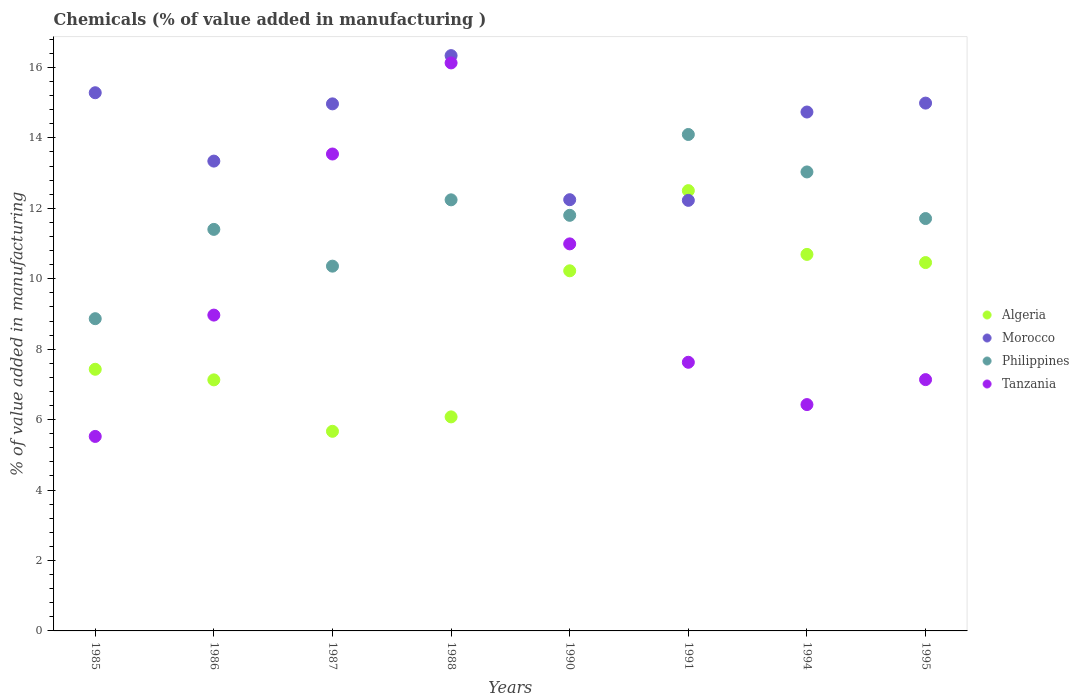How many different coloured dotlines are there?
Give a very brief answer. 4. Is the number of dotlines equal to the number of legend labels?
Keep it short and to the point. Yes. What is the value added in manufacturing chemicals in Tanzania in 1995?
Your response must be concise. 7.14. Across all years, what is the maximum value added in manufacturing chemicals in Philippines?
Your response must be concise. 14.1. Across all years, what is the minimum value added in manufacturing chemicals in Morocco?
Your response must be concise. 12.23. In which year was the value added in manufacturing chemicals in Algeria maximum?
Provide a succinct answer. 1991. What is the total value added in manufacturing chemicals in Philippines in the graph?
Give a very brief answer. 93.51. What is the difference between the value added in manufacturing chemicals in Tanzania in 1985 and that in 1994?
Give a very brief answer. -0.9. What is the difference between the value added in manufacturing chemicals in Algeria in 1988 and the value added in manufacturing chemicals in Morocco in 1995?
Offer a very short reply. -8.91. What is the average value added in manufacturing chemicals in Morocco per year?
Provide a succinct answer. 14.27. In the year 1987, what is the difference between the value added in manufacturing chemicals in Morocco and value added in manufacturing chemicals in Tanzania?
Make the answer very short. 1.42. What is the ratio of the value added in manufacturing chemicals in Tanzania in 1987 to that in 1990?
Give a very brief answer. 1.23. Is the difference between the value added in manufacturing chemicals in Morocco in 1988 and 1994 greater than the difference between the value added in manufacturing chemicals in Tanzania in 1988 and 1994?
Your response must be concise. No. What is the difference between the highest and the second highest value added in manufacturing chemicals in Philippines?
Your response must be concise. 1.06. What is the difference between the highest and the lowest value added in manufacturing chemicals in Tanzania?
Your answer should be very brief. 10.61. Is the sum of the value added in manufacturing chemicals in Tanzania in 1985 and 1987 greater than the maximum value added in manufacturing chemicals in Algeria across all years?
Offer a terse response. Yes. Is it the case that in every year, the sum of the value added in manufacturing chemicals in Morocco and value added in manufacturing chemicals in Philippines  is greater than the value added in manufacturing chemicals in Algeria?
Your answer should be very brief. Yes. Does the value added in manufacturing chemicals in Algeria monotonically increase over the years?
Keep it short and to the point. No. How many dotlines are there?
Offer a terse response. 4. How many years are there in the graph?
Offer a terse response. 8. What is the difference between two consecutive major ticks on the Y-axis?
Make the answer very short. 2. Are the values on the major ticks of Y-axis written in scientific E-notation?
Your response must be concise. No. How are the legend labels stacked?
Give a very brief answer. Vertical. What is the title of the graph?
Your response must be concise. Chemicals (% of value added in manufacturing ). Does "France" appear as one of the legend labels in the graph?
Make the answer very short. No. What is the label or title of the X-axis?
Make the answer very short. Years. What is the label or title of the Y-axis?
Keep it short and to the point. % of value added in manufacturing. What is the % of value added in manufacturing of Algeria in 1985?
Your response must be concise. 7.43. What is the % of value added in manufacturing of Morocco in 1985?
Keep it short and to the point. 15.28. What is the % of value added in manufacturing in Philippines in 1985?
Give a very brief answer. 8.87. What is the % of value added in manufacturing in Tanzania in 1985?
Offer a terse response. 5.52. What is the % of value added in manufacturing in Algeria in 1986?
Your answer should be very brief. 7.13. What is the % of value added in manufacturing in Morocco in 1986?
Offer a very short reply. 13.34. What is the % of value added in manufacturing of Philippines in 1986?
Provide a succinct answer. 11.4. What is the % of value added in manufacturing in Tanzania in 1986?
Provide a succinct answer. 8.97. What is the % of value added in manufacturing of Algeria in 1987?
Offer a very short reply. 5.67. What is the % of value added in manufacturing of Morocco in 1987?
Keep it short and to the point. 14.97. What is the % of value added in manufacturing in Philippines in 1987?
Ensure brevity in your answer.  10.36. What is the % of value added in manufacturing of Tanzania in 1987?
Your response must be concise. 13.54. What is the % of value added in manufacturing in Algeria in 1988?
Offer a terse response. 6.08. What is the % of value added in manufacturing of Morocco in 1988?
Ensure brevity in your answer.  16.34. What is the % of value added in manufacturing of Philippines in 1988?
Provide a succinct answer. 12.24. What is the % of value added in manufacturing in Tanzania in 1988?
Your answer should be very brief. 16.13. What is the % of value added in manufacturing in Algeria in 1990?
Offer a terse response. 10.23. What is the % of value added in manufacturing in Morocco in 1990?
Make the answer very short. 12.25. What is the % of value added in manufacturing in Philippines in 1990?
Make the answer very short. 11.8. What is the % of value added in manufacturing in Tanzania in 1990?
Keep it short and to the point. 10.99. What is the % of value added in manufacturing in Algeria in 1991?
Give a very brief answer. 12.5. What is the % of value added in manufacturing in Morocco in 1991?
Keep it short and to the point. 12.23. What is the % of value added in manufacturing in Philippines in 1991?
Ensure brevity in your answer.  14.1. What is the % of value added in manufacturing in Tanzania in 1991?
Offer a terse response. 7.63. What is the % of value added in manufacturing in Algeria in 1994?
Offer a very short reply. 10.69. What is the % of value added in manufacturing of Morocco in 1994?
Provide a short and direct response. 14.74. What is the % of value added in manufacturing in Philippines in 1994?
Provide a short and direct response. 13.03. What is the % of value added in manufacturing in Tanzania in 1994?
Give a very brief answer. 6.43. What is the % of value added in manufacturing of Algeria in 1995?
Provide a succinct answer. 10.46. What is the % of value added in manufacturing of Morocco in 1995?
Your answer should be compact. 14.99. What is the % of value added in manufacturing in Philippines in 1995?
Give a very brief answer. 11.71. What is the % of value added in manufacturing of Tanzania in 1995?
Give a very brief answer. 7.14. Across all years, what is the maximum % of value added in manufacturing in Algeria?
Ensure brevity in your answer.  12.5. Across all years, what is the maximum % of value added in manufacturing of Morocco?
Ensure brevity in your answer.  16.34. Across all years, what is the maximum % of value added in manufacturing of Philippines?
Ensure brevity in your answer.  14.1. Across all years, what is the maximum % of value added in manufacturing in Tanzania?
Make the answer very short. 16.13. Across all years, what is the minimum % of value added in manufacturing in Algeria?
Your response must be concise. 5.67. Across all years, what is the minimum % of value added in manufacturing of Morocco?
Offer a very short reply. 12.23. Across all years, what is the minimum % of value added in manufacturing in Philippines?
Offer a terse response. 8.87. Across all years, what is the minimum % of value added in manufacturing of Tanzania?
Provide a succinct answer. 5.52. What is the total % of value added in manufacturing in Algeria in the graph?
Provide a succinct answer. 70.19. What is the total % of value added in manufacturing in Morocco in the graph?
Offer a terse response. 114.12. What is the total % of value added in manufacturing in Philippines in the graph?
Your answer should be very brief. 93.51. What is the total % of value added in manufacturing in Tanzania in the graph?
Provide a succinct answer. 76.35. What is the difference between the % of value added in manufacturing of Algeria in 1985 and that in 1986?
Provide a short and direct response. 0.3. What is the difference between the % of value added in manufacturing in Morocco in 1985 and that in 1986?
Ensure brevity in your answer.  1.94. What is the difference between the % of value added in manufacturing in Philippines in 1985 and that in 1986?
Offer a terse response. -2.54. What is the difference between the % of value added in manufacturing in Tanzania in 1985 and that in 1986?
Keep it short and to the point. -3.45. What is the difference between the % of value added in manufacturing of Algeria in 1985 and that in 1987?
Give a very brief answer. 1.76. What is the difference between the % of value added in manufacturing of Morocco in 1985 and that in 1987?
Your answer should be very brief. 0.32. What is the difference between the % of value added in manufacturing in Philippines in 1985 and that in 1987?
Your response must be concise. -1.49. What is the difference between the % of value added in manufacturing of Tanzania in 1985 and that in 1987?
Your answer should be compact. -8.02. What is the difference between the % of value added in manufacturing of Algeria in 1985 and that in 1988?
Offer a very short reply. 1.35. What is the difference between the % of value added in manufacturing of Morocco in 1985 and that in 1988?
Offer a terse response. -1.05. What is the difference between the % of value added in manufacturing in Philippines in 1985 and that in 1988?
Offer a very short reply. -3.38. What is the difference between the % of value added in manufacturing of Tanzania in 1985 and that in 1988?
Your answer should be compact. -10.61. What is the difference between the % of value added in manufacturing in Algeria in 1985 and that in 1990?
Keep it short and to the point. -2.8. What is the difference between the % of value added in manufacturing of Morocco in 1985 and that in 1990?
Provide a succinct answer. 3.04. What is the difference between the % of value added in manufacturing of Philippines in 1985 and that in 1990?
Provide a short and direct response. -2.94. What is the difference between the % of value added in manufacturing of Tanzania in 1985 and that in 1990?
Give a very brief answer. -5.47. What is the difference between the % of value added in manufacturing of Algeria in 1985 and that in 1991?
Offer a terse response. -5.07. What is the difference between the % of value added in manufacturing of Morocco in 1985 and that in 1991?
Offer a terse response. 3.06. What is the difference between the % of value added in manufacturing of Philippines in 1985 and that in 1991?
Your answer should be compact. -5.23. What is the difference between the % of value added in manufacturing in Tanzania in 1985 and that in 1991?
Provide a short and direct response. -2.11. What is the difference between the % of value added in manufacturing of Algeria in 1985 and that in 1994?
Make the answer very short. -3.26. What is the difference between the % of value added in manufacturing in Morocco in 1985 and that in 1994?
Offer a terse response. 0.55. What is the difference between the % of value added in manufacturing of Philippines in 1985 and that in 1994?
Make the answer very short. -4.17. What is the difference between the % of value added in manufacturing in Tanzania in 1985 and that in 1994?
Your response must be concise. -0.9. What is the difference between the % of value added in manufacturing in Algeria in 1985 and that in 1995?
Provide a short and direct response. -3.03. What is the difference between the % of value added in manufacturing in Morocco in 1985 and that in 1995?
Give a very brief answer. 0.29. What is the difference between the % of value added in manufacturing of Philippines in 1985 and that in 1995?
Give a very brief answer. -2.84. What is the difference between the % of value added in manufacturing of Tanzania in 1985 and that in 1995?
Offer a very short reply. -1.61. What is the difference between the % of value added in manufacturing of Algeria in 1986 and that in 1987?
Provide a short and direct response. 1.46. What is the difference between the % of value added in manufacturing in Morocco in 1986 and that in 1987?
Give a very brief answer. -1.63. What is the difference between the % of value added in manufacturing of Philippines in 1986 and that in 1987?
Provide a short and direct response. 1.04. What is the difference between the % of value added in manufacturing of Tanzania in 1986 and that in 1987?
Provide a short and direct response. -4.57. What is the difference between the % of value added in manufacturing of Algeria in 1986 and that in 1988?
Offer a very short reply. 1.05. What is the difference between the % of value added in manufacturing in Morocco in 1986 and that in 1988?
Your answer should be compact. -3. What is the difference between the % of value added in manufacturing in Philippines in 1986 and that in 1988?
Provide a short and direct response. -0.84. What is the difference between the % of value added in manufacturing in Tanzania in 1986 and that in 1988?
Provide a short and direct response. -7.16. What is the difference between the % of value added in manufacturing of Algeria in 1986 and that in 1990?
Ensure brevity in your answer.  -3.1. What is the difference between the % of value added in manufacturing in Morocco in 1986 and that in 1990?
Make the answer very short. 1.1. What is the difference between the % of value added in manufacturing of Philippines in 1986 and that in 1990?
Your answer should be compact. -0.4. What is the difference between the % of value added in manufacturing in Tanzania in 1986 and that in 1990?
Offer a very short reply. -2.02. What is the difference between the % of value added in manufacturing of Algeria in 1986 and that in 1991?
Provide a short and direct response. -5.37. What is the difference between the % of value added in manufacturing in Morocco in 1986 and that in 1991?
Your response must be concise. 1.11. What is the difference between the % of value added in manufacturing of Philippines in 1986 and that in 1991?
Ensure brevity in your answer.  -2.7. What is the difference between the % of value added in manufacturing of Tanzania in 1986 and that in 1991?
Provide a short and direct response. 1.34. What is the difference between the % of value added in manufacturing of Algeria in 1986 and that in 1994?
Your answer should be compact. -3.56. What is the difference between the % of value added in manufacturing of Morocco in 1986 and that in 1994?
Your answer should be very brief. -1.39. What is the difference between the % of value added in manufacturing of Philippines in 1986 and that in 1994?
Offer a terse response. -1.63. What is the difference between the % of value added in manufacturing of Tanzania in 1986 and that in 1994?
Provide a short and direct response. 2.54. What is the difference between the % of value added in manufacturing in Algeria in 1986 and that in 1995?
Make the answer very short. -3.33. What is the difference between the % of value added in manufacturing in Morocco in 1986 and that in 1995?
Your response must be concise. -1.65. What is the difference between the % of value added in manufacturing in Philippines in 1986 and that in 1995?
Ensure brevity in your answer.  -0.31. What is the difference between the % of value added in manufacturing in Tanzania in 1986 and that in 1995?
Offer a very short reply. 1.83. What is the difference between the % of value added in manufacturing in Algeria in 1987 and that in 1988?
Your answer should be compact. -0.41. What is the difference between the % of value added in manufacturing in Morocco in 1987 and that in 1988?
Your response must be concise. -1.37. What is the difference between the % of value added in manufacturing of Philippines in 1987 and that in 1988?
Offer a terse response. -1.88. What is the difference between the % of value added in manufacturing in Tanzania in 1987 and that in 1988?
Your answer should be very brief. -2.59. What is the difference between the % of value added in manufacturing of Algeria in 1987 and that in 1990?
Keep it short and to the point. -4.56. What is the difference between the % of value added in manufacturing of Morocco in 1987 and that in 1990?
Give a very brief answer. 2.72. What is the difference between the % of value added in manufacturing in Philippines in 1987 and that in 1990?
Your answer should be very brief. -1.44. What is the difference between the % of value added in manufacturing of Tanzania in 1987 and that in 1990?
Give a very brief answer. 2.55. What is the difference between the % of value added in manufacturing in Algeria in 1987 and that in 1991?
Your response must be concise. -6.83. What is the difference between the % of value added in manufacturing of Morocco in 1987 and that in 1991?
Offer a very short reply. 2.74. What is the difference between the % of value added in manufacturing of Philippines in 1987 and that in 1991?
Keep it short and to the point. -3.74. What is the difference between the % of value added in manufacturing of Tanzania in 1987 and that in 1991?
Your answer should be compact. 5.91. What is the difference between the % of value added in manufacturing of Algeria in 1987 and that in 1994?
Your answer should be very brief. -5.02. What is the difference between the % of value added in manufacturing of Morocco in 1987 and that in 1994?
Ensure brevity in your answer.  0.23. What is the difference between the % of value added in manufacturing of Philippines in 1987 and that in 1994?
Make the answer very short. -2.68. What is the difference between the % of value added in manufacturing of Tanzania in 1987 and that in 1994?
Offer a very short reply. 7.12. What is the difference between the % of value added in manufacturing of Algeria in 1987 and that in 1995?
Provide a short and direct response. -4.79. What is the difference between the % of value added in manufacturing in Morocco in 1987 and that in 1995?
Ensure brevity in your answer.  -0.02. What is the difference between the % of value added in manufacturing in Philippines in 1987 and that in 1995?
Offer a terse response. -1.35. What is the difference between the % of value added in manufacturing of Tanzania in 1987 and that in 1995?
Ensure brevity in your answer.  6.41. What is the difference between the % of value added in manufacturing of Algeria in 1988 and that in 1990?
Offer a very short reply. -4.15. What is the difference between the % of value added in manufacturing in Morocco in 1988 and that in 1990?
Your answer should be compact. 4.09. What is the difference between the % of value added in manufacturing of Philippines in 1988 and that in 1990?
Your response must be concise. 0.44. What is the difference between the % of value added in manufacturing of Tanzania in 1988 and that in 1990?
Ensure brevity in your answer.  5.14. What is the difference between the % of value added in manufacturing of Algeria in 1988 and that in 1991?
Your answer should be compact. -6.42. What is the difference between the % of value added in manufacturing in Morocco in 1988 and that in 1991?
Your answer should be compact. 4.11. What is the difference between the % of value added in manufacturing of Philippines in 1988 and that in 1991?
Give a very brief answer. -1.86. What is the difference between the % of value added in manufacturing of Tanzania in 1988 and that in 1991?
Your answer should be very brief. 8.5. What is the difference between the % of value added in manufacturing of Algeria in 1988 and that in 1994?
Keep it short and to the point. -4.61. What is the difference between the % of value added in manufacturing in Morocco in 1988 and that in 1994?
Give a very brief answer. 1.6. What is the difference between the % of value added in manufacturing in Philippines in 1988 and that in 1994?
Offer a very short reply. -0.79. What is the difference between the % of value added in manufacturing of Tanzania in 1988 and that in 1994?
Provide a succinct answer. 9.7. What is the difference between the % of value added in manufacturing of Algeria in 1988 and that in 1995?
Keep it short and to the point. -4.38. What is the difference between the % of value added in manufacturing of Morocco in 1988 and that in 1995?
Ensure brevity in your answer.  1.35. What is the difference between the % of value added in manufacturing of Philippines in 1988 and that in 1995?
Keep it short and to the point. 0.53. What is the difference between the % of value added in manufacturing of Tanzania in 1988 and that in 1995?
Ensure brevity in your answer.  8.99. What is the difference between the % of value added in manufacturing in Algeria in 1990 and that in 1991?
Your response must be concise. -2.28. What is the difference between the % of value added in manufacturing of Morocco in 1990 and that in 1991?
Offer a terse response. 0.02. What is the difference between the % of value added in manufacturing in Philippines in 1990 and that in 1991?
Your answer should be very brief. -2.3. What is the difference between the % of value added in manufacturing of Tanzania in 1990 and that in 1991?
Your answer should be compact. 3.36. What is the difference between the % of value added in manufacturing in Algeria in 1990 and that in 1994?
Make the answer very short. -0.47. What is the difference between the % of value added in manufacturing in Morocco in 1990 and that in 1994?
Keep it short and to the point. -2.49. What is the difference between the % of value added in manufacturing in Philippines in 1990 and that in 1994?
Ensure brevity in your answer.  -1.23. What is the difference between the % of value added in manufacturing in Tanzania in 1990 and that in 1994?
Your response must be concise. 4.56. What is the difference between the % of value added in manufacturing of Algeria in 1990 and that in 1995?
Offer a very short reply. -0.23. What is the difference between the % of value added in manufacturing of Morocco in 1990 and that in 1995?
Offer a very short reply. -2.74. What is the difference between the % of value added in manufacturing of Philippines in 1990 and that in 1995?
Provide a short and direct response. 0.09. What is the difference between the % of value added in manufacturing in Tanzania in 1990 and that in 1995?
Provide a succinct answer. 3.85. What is the difference between the % of value added in manufacturing in Algeria in 1991 and that in 1994?
Make the answer very short. 1.81. What is the difference between the % of value added in manufacturing in Morocco in 1991 and that in 1994?
Make the answer very short. -2.51. What is the difference between the % of value added in manufacturing of Philippines in 1991 and that in 1994?
Provide a succinct answer. 1.06. What is the difference between the % of value added in manufacturing in Tanzania in 1991 and that in 1994?
Keep it short and to the point. 1.2. What is the difference between the % of value added in manufacturing of Algeria in 1991 and that in 1995?
Give a very brief answer. 2.04. What is the difference between the % of value added in manufacturing in Morocco in 1991 and that in 1995?
Keep it short and to the point. -2.76. What is the difference between the % of value added in manufacturing in Philippines in 1991 and that in 1995?
Your response must be concise. 2.39. What is the difference between the % of value added in manufacturing in Tanzania in 1991 and that in 1995?
Ensure brevity in your answer.  0.49. What is the difference between the % of value added in manufacturing in Algeria in 1994 and that in 1995?
Your answer should be compact. 0.23. What is the difference between the % of value added in manufacturing of Morocco in 1994 and that in 1995?
Offer a very short reply. -0.25. What is the difference between the % of value added in manufacturing of Philippines in 1994 and that in 1995?
Ensure brevity in your answer.  1.32. What is the difference between the % of value added in manufacturing of Tanzania in 1994 and that in 1995?
Give a very brief answer. -0.71. What is the difference between the % of value added in manufacturing of Algeria in 1985 and the % of value added in manufacturing of Morocco in 1986?
Your answer should be very brief. -5.91. What is the difference between the % of value added in manufacturing in Algeria in 1985 and the % of value added in manufacturing in Philippines in 1986?
Offer a terse response. -3.97. What is the difference between the % of value added in manufacturing in Algeria in 1985 and the % of value added in manufacturing in Tanzania in 1986?
Offer a very short reply. -1.54. What is the difference between the % of value added in manufacturing in Morocco in 1985 and the % of value added in manufacturing in Philippines in 1986?
Offer a very short reply. 3.88. What is the difference between the % of value added in manufacturing in Morocco in 1985 and the % of value added in manufacturing in Tanzania in 1986?
Offer a very short reply. 6.31. What is the difference between the % of value added in manufacturing of Philippines in 1985 and the % of value added in manufacturing of Tanzania in 1986?
Provide a short and direct response. -0.1. What is the difference between the % of value added in manufacturing of Algeria in 1985 and the % of value added in manufacturing of Morocco in 1987?
Offer a terse response. -7.54. What is the difference between the % of value added in manufacturing of Algeria in 1985 and the % of value added in manufacturing of Philippines in 1987?
Offer a terse response. -2.93. What is the difference between the % of value added in manufacturing in Algeria in 1985 and the % of value added in manufacturing in Tanzania in 1987?
Your response must be concise. -6.11. What is the difference between the % of value added in manufacturing in Morocco in 1985 and the % of value added in manufacturing in Philippines in 1987?
Offer a very short reply. 4.92. What is the difference between the % of value added in manufacturing of Morocco in 1985 and the % of value added in manufacturing of Tanzania in 1987?
Keep it short and to the point. 1.74. What is the difference between the % of value added in manufacturing in Philippines in 1985 and the % of value added in manufacturing in Tanzania in 1987?
Your answer should be compact. -4.68. What is the difference between the % of value added in manufacturing in Algeria in 1985 and the % of value added in manufacturing in Morocco in 1988?
Your response must be concise. -8.91. What is the difference between the % of value added in manufacturing in Algeria in 1985 and the % of value added in manufacturing in Philippines in 1988?
Your response must be concise. -4.81. What is the difference between the % of value added in manufacturing in Algeria in 1985 and the % of value added in manufacturing in Tanzania in 1988?
Offer a terse response. -8.7. What is the difference between the % of value added in manufacturing of Morocco in 1985 and the % of value added in manufacturing of Philippines in 1988?
Provide a short and direct response. 3.04. What is the difference between the % of value added in manufacturing in Morocco in 1985 and the % of value added in manufacturing in Tanzania in 1988?
Your answer should be very brief. -0.85. What is the difference between the % of value added in manufacturing of Philippines in 1985 and the % of value added in manufacturing of Tanzania in 1988?
Make the answer very short. -7.26. What is the difference between the % of value added in manufacturing of Algeria in 1985 and the % of value added in manufacturing of Morocco in 1990?
Give a very brief answer. -4.82. What is the difference between the % of value added in manufacturing of Algeria in 1985 and the % of value added in manufacturing of Philippines in 1990?
Ensure brevity in your answer.  -4.37. What is the difference between the % of value added in manufacturing of Algeria in 1985 and the % of value added in manufacturing of Tanzania in 1990?
Keep it short and to the point. -3.56. What is the difference between the % of value added in manufacturing in Morocco in 1985 and the % of value added in manufacturing in Philippines in 1990?
Provide a succinct answer. 3.48. What is the difference between the % of value added in manufacturing of Morocco in 1985 and the % of value added in manufacturing of Tanzania in 1990?
Your response must be concise. 4.29. What is the difference between the % of value added in manufacturing of Philippines in 1985 and the % of value added in manufacturing of Tanzania in 1990?
Offer a terse response. -2.12. What is the difference between the % of value added in manufacturing in Algeria in 1985 and the % of value added in manufacturing in Morocco in 1991?
Offer a very short reply. -4.8. What is the difference between the % of value added in manufacturing of Algeria in 1985 and the % of value added in manufacturing of Philippines in 1991?
Offer a very short reply. -6.67. What is the difference between the % of value added in manufacturing in Algeria in 1985 and the % of value added in manufacturing in Tanzania in 1991?
Your answer should be very brief. -0.2. What is the difference between the % of value added in manufacturing in Morocco in 1985 and the % of value added in manufacturing in Philippines in 1991?
Offer a very short reply. 1.19. What is the difference between the % of value added in manufacturing in Morocco in 1985 and the % of value added in manufacturing in Tanzania in 1991?
Make the answer very short. 7.65. What is the difference between the % of value added in manufacturing in Philippines in 1985 and the % of value added in manufacturing in Tanzania in 1991?
Offer a very short reply. 1.24. What is the difference between the % of value added in manufacturing in Algeria in 1985 and the % of value added in manufacturing in Morocco in 1994?
Provide a succinct answer. -7.31. What is the difference between the % of value added in manufacturing of Algeria in 1985 and the % of value added in manufacturing of Philippines in 1994?
Ensure brevity in your answer.  -5.6. What is the difference between the % of value added in manufacturing of Algeria in 1985 and the % of value added in manufacturing of Tanzania in 1994?
Offer a terse response. 1. What is the difference between the % of value added in manufacturing in Morocco in 1985 and the % of value added in manufacturing in Philippines in 1994?
Keep it short and to the point. 2.25. What is the difference between the % of value added in manufacturing of Morocco in 1985 and the % of value added in manufacturing of Tanzania in 1994?
Your response must be concise. 8.86. What is the difference between the % of value added in manufacturing of Philippines in 1985 and the % of value added in manufacturing of Tanzania in 1994?
Keep it short and to the point. 2.44. What is the difference between the % of value added in manufacturing of Algeria in 1985 and the % of value added in manufacturing of Morocco in 1995?
Ensure brevity in your answer.  -7.56. What is the difference between the % of value added in manufacturing of Algeria in 1985 and the % of value added in manufacturing of Philippines in 1995?
Keep it short and to the point. -4.28. What is the difference between the % of value added in manufacturing of Algeria in 1985 and the % of value added in manufacturing of Tanzania in 1995?
Ensure brevity in your answer.  0.29. What is the difference between the % of value added in manufacturing of Morocco in 1985 and the % of value added in manufacturing of Philippines in 1995?
Ensure brevity in your answer.  3.57. What is the difference between the % of value added in manufacturing in Morocco in 1985 and the % of value added in manufacturing in Tanzania in 1995?
Ensure brevity in your answer.  8.15. What is the difference between the % of value added in manufacturing of Philippines in 1985 and the % of value added in manufacturing of Tanzania in 1995?
Provide a succinct answer. 1.73. What is the difference between the % of value added in manufacturing of Algeria in 1986 and the % of value added in manufacturing of Morocco in 1987?
Provide a succinct answer. -7.84. What is the difference between the % of value added in manufacturing of Algeria in 1986 and the % of value added in manufacturing of Philippines in 1987?
Ensure brevity in your answer.  -3.23. What is the difference between the % of value added in manufacturing in Algeria in 1986 and the % of value added in manufacturing in Tanzania in 1987?
Your answer should be compact. -6.41. What is the difference between the % of value added in manufacturing of Morocco in 1986 and the % of value added in manufacturing of Philippines in 1987?
Your response must be concise. 2.98. What is the difference between the % of value added in manufacturing in Morocco in 1986 and the % of value added in manufacturing in Tanzania in 1987?
Give a very brief answer. -0.2. What is the difference between the % of value added in manufacturing in Philippines in 1986 and the % of value added in manufacturing in Tanzania in 1987?
Provide a succinct answer. -2.14. What is the difference between the % of value added in manufacturing in Algeria in 1986 and the % of value added in manufacturing in Morocco in 1988?
Keep it short and to the point. -9.21. What is the difference between the % of value added in manufacturing of Algeria in 1986 and the % of value added in manufacturing of Philippines in 1988?
Keep it short and to the point. -5.11. What is the difference between the % of value added in manufacturing in Algeria in 1986 and the % of value added in manufacturing in Tanzania in 1988?
Offer a very short reply. -9. What is the difference between the % of value added in manufacturing of Morocco in 1986 and the % of value added in manufacturing of Philippines in 1988?
Provide a short and direct response. 1.1. What is the difference between the % of value added in manufacturing in Morocco in 1986 and the % of value added in manufacturing in Tanzania in 1988?
Your answer should be very brief. -2.79. What is the difference between the % of value added in manufacturing in Philippines in 1986 and the % of value added in manufacturing in Tanzania in 1988?
Provide a succinct answer. -4.73. What is the difference between the % of value added in manufacturing of Algeria in 1986 and the % of value added in manufacturing of Morocco in 1990?
Offer a very short reply. -5.12. What is the difference between the % of value added in manufacturing in Algeria in 1986 and the % of value added in manufacturing in Philippines in 1990?
Provide a succinct answer. -4.67. What is the difference between the % of value added in manufacturing in Algeria in 1986 and the % of value added in manufacturing in Tanzania in 1990?
Offer a very short reply. -3.86. What is the difference between the % of value added in manufacturing in Morocco in 1986 and the % of value added in manufacturing in Philippines in 1990?
Keep it short and to the point. 1.54. What is the difference between the % of value added in manufacturing of Morocco in 1986 and the % of value added in manufacturing of Tanzania in 1990?
Offer a terse response. 2.35. What is the difference between the % of value added in manufacturing in Philippines in 1986 and the % of value added in manufacturing in Tanzania in 1990?
Ensure brevity in your answer.  0.41. What is the difference between the % of value added in manufacturing in Algeria in 1986 and the % of value added in manufacturing in Morocco in 1991?
Offer a terse response. -5.1. What is the difference between the % of value added in manufacturing in Algeria in 1986 and the % of value added in manufacturing in Philippines in 1991?
Offer a very short reply. -6.97. What is the difference between the % of value added in manufacturing in Algeria in 1986 and the % of value added in manufacturing in Tanzania in 1991?
Offer a terse response. -0.5. What is the difference between the % of value added in manufacturing of Morocco in 1986 and the % of value added in manufacturing of Philippines in 1991?
Your response must be concise. -0.76. What is the difference between the % of value added in manufacturing of Morocco in 1986 and the % of value added in manufacturing of Tanzania in 1991?
Offer a terse response. 5.71. What is the difference between the % of value added in manufacturing in Philippines in 1986 and the % of value added in manufacturing in Tanzania in 1991?
Provide a succinct answer. 3.77. What is the difference between the % of value added in manufacturing in Algeria in 1986 and the % of value added in manufacturing in Morocco in 1994?
Provide a short and direct response. -7.61. What is the difference between the % of value added in manufacturing in Algeria in 1986 and the % of value added in manufacturing in Philippines in 1994?
Your response must be concise. -5.9. What is the difference between the % of value added in manufacturing of Algeria in 1986 and the % of value added in manufacturing of Tanzania in 1994?
Provide a short and direct response. 0.7. What is the difference between the % of value added in manufacturing of Morocco in 1986 and the % of value added in manufacturing of Philippines in 1994?
Your answer should be compact. 0.31. What is the difference between the % of value added in manufacturing of Morocco in 1986 and the % of value added in manufacturing of Tanzania in 1994?
Keep it short and to the point. 6.91. What is the difference between the % of value added in manufacturing in Philippines in 1986 and the % of value added in manufacturing in Tanzania in 1994?
Your response must be concise. 4.97. What is the difference between the % of value added in manufacturing in Algeria in 1986 and the % of value added in manufacturing in Morocco in 1995?
Provide a succinct answer. -7.86. What is the difference between the % of value added in manufacturing in Algeria in 1986 and the % of value added in manufacturing in Philippines in 1995?
Offer a terse response. -4.58. What is the difference between the % of value added in manufacturing in Algeria in 1986 and the % of value added in manufacturing in Tanzania in 1995?
Ensure brevity in your answer.  -0.01. What is the difference between the % of value added in manufacturing in Morocco in 1986 and the % of value added in manufacturing in Philippines in 1995?
Provide a succinct answer. 1.63. What is the difference between the % of value added in manufacturing of Morocco in 1986 and the % of value added in manufacturing of Tanzania in 1995?
Your response must be concise. 6.21. What is the difference between the % of value added in manufacturing in Philippines in 1986 and the % of value added in manufacturing in Tanzania in 1995?
Provide a short and direct response. 4.27. What is the difference between the % of value added in manufacturing of Algeria in 1987 and the % of value added in manufacturing of Morocco in 1988?
Your response must be concise. -10.67. What is the difference between the % of value added in manufacturing of Algeria in 1987 and the % of value added in manufacturing of Philippines in 1988?
Your response must be concise. -6.57. What is the difference between the % of value added in manufacturing of Algeria in 1987 and the % of value added in manufacturing of Tanzania in 1988?
Your answer should be very brief. -10.46. What is the difference between the % of value added in manufacturing in Morocco in 1987 and the % of value added in manufacturing in Philippines in 1988?
Your answer should be compact. 2.73. What is the difference between the % of value added in manufacturing in Morocco in 1987 and the % of value added in manufacturing in Tanzania in 1988?
Give a very brief answer. -1.16. What is the difference between the % of value added in manufacturing in Philippines in 1987 and the % of value added in manufacturing in Tanzania in 1988?
Your answer should be very brief. -5.77. What is the difference between the % of value added in manufacturing in Algeria in 1987 and the % of value added in manufacturing in Morocco in 1990?
Your answer should be very brief. -6.58. What is the difference between the % of value added in manufacturing in Algeria in 1987 and the % of value added in manufacturing in Philippines in 1990?
Provide a succinct answer. -6.13. What is the difference between the % of value added in manufacturing in Algeria in 1987 and the % of value added in manufacturing in Tanzania in 1990?
Provide a short and direct response. -5.32. What is the difference between the % of value added in manufacturing in Morocco in 1987 and the % of value added in manufacturing in Philippines in 1990?
Make the answer very short. 3.17. What is the difference between the % of value added in manufacturing in Morocco in 1987 and the % of value added in manufacturing in Tanzania in 1990?
Your response must be concise. 3.98. What is the difference between the % of value added in manufacturing of Philippines in 1987 and the % of value added in manufacturing of Tanzania in 1990?
Provide a short and direct response. -0.63. What is the difference between the % of value added in manufacturing of Algeria in 1987 and the % of value added in manufacturing of Morocco in 1991?
Your answer should be compact. -6.56. What is the difference between the % of value added in manufacturing of Algeria in 1987 and the % of value added in manufacturing of Philippines in 1991?
Your answer should be compact. -8.43. What is the difference between the % of value added in manufacturing of Algeria in 1987 and the % of value added in manufacturing of Tanzania in 1991?
Your answer should be very brief. -1.96. What is the difference between the % of value added in manufacturing of Morocco in 1987 and the % of value added in manufacturing of Philippines in 1991?
Your answer should be very brief. 0.87. What is the difference between the % of value added in manufacturing of Morocco in 1987 and the % of value added in manufacturing of Tanzania in 1991?
Provide a succinct answer. 7.34. What is the difference between the % of value added in manufacturing of Philippines in 1987 and the % of value added in manufacturing of Tanzania in 1991?
Your response must be concise. 2.73. What is the difference between the % of value added in manufacturing in Algeria in 1987 and the % of value added in manufacturing in Morocco in 1994?
Offer a very short reply. -9.07. What is the difference between the % of value added in manufacturing in Algeria in 1987 and the % of value added in manufacturing in Philippines in 1994?
Your answer should be very brief. -7.37. What is the difference between the % of value added in manufacturing of Algeria in 1987 and the % of value added in manufacturing of Tanzania in 1994?
Make the answer very short. -0.76. What is the difference between the % of value added in manufacturing in Morocco in 1987 and the % of value added in manufacturing in Philippines in 1994?
Keep it short and to the point. 1.93. What is the difference between the % of value added in manufacturing in Morocco in 1987 and the % of value added in manufacturing in Tanzania in 1994?
Give a very brief answer. 8.54. What is the difference between the % of value added in manufacturing of Philippines in 1987 and the % of value added in manufacturing of Tanzania in 1994?
Offer a terse response. 3.93. What is the difference between the % of value added in manufacturing in Algeria in 1987 and the % of value added in manufacturing in Morocco in 1995?
Give a very brief answer. -9.32. What is the difference between the % of value added in manufacturing in Algeria in 1987 and the % of value added in manufacturing in Philippines in 1995?
Give a very brief answer. -6.04. What is the difference between the % of value added in manufacturing in Algeria in 1987 and the % of value added in manufacturing in Tanzania in 1995?
Make the answer very short. -1.47. What is the difference between the % of value added in manufacturing of Morocco in 1987 and the % of value added in manufacturing of Philippines in 1995?
Give a very brief answer. 3.26. What is the difference between the % of value added in manufacturing of Morocco in 1987 and the % of value added in manufacturing of Tanzania in 1995?
Your answer should be compact. 7.83. What is the difference between the % of value added in manufacturing of Philippines in 1987 and the % of value added in manufacturing of Tanzania in 1995?
Provide a short and direct response. 3.22. What is the difference between the % of value added in manufacturing in Algeria in 1988 and the % of value added in manufacturing in Morocco in 1990?
Provide a succinct answer. -6.17. What is the difference between the % of value added in manufacturing of Algeria in 1988 and the % of value added in manufacturing of Philippines in 1990?
Ensure brevity in your answer.  -5.72. What is the difference between the % of value added in manufacturing in Algeria in 1988 and the % of value added in manufacturing in Tanzania in 1990?
Ensure brevity in your answer.  -4.91. What is the difference between the % of value added in manufacturing in Morocco in 1988 and the % of value added in manufacturing in Philippines in 1990?
Your response must be concise. 4.54. What is the difference between the % of value added in manufacturing in Morocco in 1988 and the % of value added in manufacturing in Tanzania in 1990?
Give a very brief answer. 5.35. What is the difference between the % of value added in manufacturing of Philippines in 1988 and the % of value added in manufacturing of Tanzania in 1990?
Provide a short and direct response. 1.25. What is the difference between the % of value added in manufacturing in Algeria in 1988 and the % of value added in manufacturing in Morocco in 1991?
Ensure brevity in your answer.  -6.15. What is the difference between the % of value added in manufacturing in Algeria in 1988 and the % of value added in manufacturing in Philippines in 1991?
Ensure brevity in your answer.  -8.02. What is the difference between the % of value added in manufacturing in Algeria in 1988 and the % of value added in manufacturing in Tanzania in 1991?
Your answer should be very brief. -1.55. What is the difference between the % of value added in manufacturing in Morocco in 1988 and the % of value added in manufacturing in Philippines in 1991?
Provide a short and direct response. 2.24. What is the difference between the % of value added in manufacturing of Morocco in 1988 and the % of value added in manufacturing of Tanzania in 1991?
Provide a short and direct response. 8.71. What is the difference between the % of value added in manufacturing in Philippines in 1988 and the % of value added in manufacturing in Tanzania in 1991?
Ensure brevity in your answer.  4.61. What is the difference between the % of value added in manufacturing of Algeria in 1988 and the % of value added in manufacturing of Morocco in 1994?
Make the answer very short. -8.66. What is the difference between the % of value added in manufacturing in Algeria in 1988 and the % of value added in manufacturing in Philippines in 1994?
Your answer should be very brief. -6.96. What is the difference between the % of value added in manufacturing of Algeria in 1988 and the % of value added in manufacturing of Tanzania in 1994?
Your answer should be very brief. -0.35. What is the difference between the % of value added in manufacturing of Morocco in 1988 and the % of value added in manufacturing of Philippines in 1994?
Your answer should be very brief. 3.3. What is the difference between the % of value added in manufacturing of Morocco in 1988 and the % of value added in manufacturing of Tanzania in 1994?
Keep it short and to the point. 9.91. What is the difference between the % of value added in manufacturing in Philippines in 1988 and the % of value added in manufacturing in Tanzania in 1994?
Your response must be concise. 5.81. What is the difference between the % of value added in manufacturing in Algeria in 1988 and the % of value added in manufacturing in Morocco in 1995?
Your answer should be very brief. -8.91. What is the difference between the % of value added in manufacturing in Algeria in 1988 and the % of value added in manufacturing in Philippines in 1995?
Ensure brevity in your answer.  -5.63. What is the difference between the % of value added in manufacturing in Algeria in 1988 and the % of value added in manufacturing in Tanzania in 1995?
Give a very brief answer. -1.06. What is the difference between the % of value added in manufacturing in Morocco in 1988 and the % of value added in manufacturing in Philippines in 1995?
Your response must be concise. 4.63. What is the difference between the % of value added in manufacturing in Morocco in 1988 and the % of value added in manufacturing in Tanzania in 1995?
Make the answer very short. 9.2. What is the difference between the % of value added in manufacturing of Philippines in 1988 and the % of value added in manufacturing of Tanzania in 1995?
Offer a very short reply. 5.11. What is the difference between the % of value added in manufacturing of Algeria in 1990 and the % of value added in manufacturing of Morocco in 1991?
Give a very brief answer. -2. What is the difference between the % of value added in manufacturing in Algeria in 1990 and the % of value added in manufacturing in Philippines in 1991?
Your answer should be compact. -3.87. What is the difference between the % of value added in manufacturing in Algeria in 1990 and the % of value added in manufacturing in Tanzania in 1991?
Your response must be concise. 2.6. What is the difference between the % of value added in manufacturing of Morocco in 1990 and the % of value added in manufacturing of Philippines in 1991?
Give a very brief answer. -1.85. What is the difference between the % of value added in manufacturing in Morocco in 1990 and the % of value added in manufacturing in Tanzania in 1991?
Offer a very short reply. 4.62. What is the difference between the % of value added in manufacturing in Philippines in 1990 and the % of value added in manufacturing in Tanzania in 1991?
Provide a succinct answer. 4.17. What is the difference between the % of value added in manufacturing in Algeria in 1990 and the % of value added in manufacturing in Morocco in 1994?
Keep it short and to the point. -4.51. What is the difference between the % of value added in manufacturing of Algeria in 1990 and the % of value added in manufacturing of Philippines in 1994?
Your answer should be very brief. -2.81. What is the difference between the % of value added in manufacturing of Algeria in 1990 and the % of value added in manufacturing of Tanzania in 1994?
Ensure brevity in your answer.  3.8. What is the difference between the % of value added in manufacturing of Morocco in 1990 and the % of value added in manufacturing of Philippines in 1994?
Your answer should be compact. -0.79. What is the difference between the % of value added in manufacturing in Morocco in 1990 and the % of value added in manufacturing in Tanzania in 1994?
Your answer should be very brief. 5.82. What is the difference between the % of value added in manufacturing in Philippines in 1990 and the % of value added in manufacturing in Tanzania in 1994?
Offer a very short reply. 5.37. What is the difference between the % of value added in manufacturing of Algeria in 1990 and the % of value added in manufacturing of Morocco in 1995?
Provide a succinct answer. -4.76. What is the difference between the % of value added in manufacturing of Algeria in 1990 and the % of value added in manufacturing of Philippines in 1995?
Give a very brief answer. -1.48. What is the difference between the % of value added in manufacturing of Algeria in 1990 and the % of value added in manufacturing of Tanzania in 1995?
Your response must be concise. 3.09. What is the difference between the % of value added in manufacturing in Morocco in 1990 and the % of value added in manufacturing in Philippines in 1995?
Keep it short and to the point. 0.54. What is the difference between the % of value added in manufacturing of Morocco in 1990 and the % of value added in manufacturing of Tanzania in 1995?
Your response must be concise. 5.11. What is the difference between the % of value added in manufacturing of Philippines in 1990 and the % of value added in manufacturing of Tanzania in 1995?
Offer a terse response. 4.67. What is the difference between the % of value added in manufacturing of Algeria in 1991 and the % of value added in manufacturing of Morocco in 1994?
Ensure brevity in your answer.  -2.23. What is the difference between the % of value added in manufacturing in Algeria in 1991 and the % of value added in manufacturing in Philippines in 1994?
Keep it short and to the point. -0.53. What is the difference between the % of value added in manufacturing of Algeria in 1991 and the % of value added in manufacturing of Tanzania in 1994?
Keep it short and to the point. 6.08. What is the difference between the % of value added in manufacturing of Morocco in 1991 and the % of value added in manufacturing of Philippines in 1994?
Offer a terse response. -0.81. What is the difference between the % of value added in manufacturing in Morocco in 1991 and the % of value added in manufacturing in Tanzania in 1994?
Make the answer very short. 5.8. What is the difference between the % of value added in manufacturing in Philippines in 1991 and the % of value added in manufacturing in Tanzania in 1994?
Your answer should be very brief. 7.67. What is the difference between the % of value added in manufacturing in Algeria in 1991 and the % of value added in manufacturing in Morocco in 1995?
Ensure brevity in your answer.  -2.49. What is the difference between the % of value added in manufacturing in Algeria in 1991 and the % of value added in manufacturing in Philippines in 1995?
Your answer should be very brief. 0.79. What is the difference between the % of value added in manufacturing of Algeria in 1991 and the % of value added in manufacturing of Tanzania in 1995?
Your answer should be very brief. 5.37. What is the difference between the % of value added in manufacturing in Morocco in 1991 and the % of value added in manufacturing in Philippines in 1995?
Give a very brief answer. 0.52. What is the difference between the % of value added in manufacturing in Morocco in 1991 and the % of value added in manufacturing in Tanzania in 1995?
Keep it short and to the point. 5.09. What is the difference between the % of value added in manufacturing of Philippines in 1991 and the % of value added in manufacturing of Tanzania in 1995?
Provide a short and direct response. 6.96. What is the difference between the % of value added in manufacturing of Algeria in 1994 and the % of value added in manufacturing of Morocco in 1995?
Offer a terse response. -4.3. What is the difference between the % of value added in manufacturing in Algeria in 1994 and the % of value added in manufacturing in Philippines in 1995?
Give a very brief answer. -1.02. What is the difference between the % of value added in manufacturing in Algeria in 1994 and the % of value added in manufacturing in Tanzania in 1995?
Your answer should be compact. 3.56. What is the difference between the % of value added in manufacturing of Morocco in 1994 and the % of value added in manufacturing of Philippines in 1995?
Give a very brief answer. 3.03. What is the difference between the % of value added in manufacturing in Morocco in 1994 and the % of value added in manufacturing in Tanzania in 1995?
Offer a terse response. 7.6. What is the difference between the % of value added in manufacturing of Philippines in 1994 and the % of value added in manufacturing of Tanzania in 1995?
Provide a succinct answer. 5.9. What is the average % of value added in manufacturing in Algeria per year?
Offer a terse response. 8.77. What is the average % of value added in manufacturing of Morocco per year?
Make the answer very short. 14.27. What is the average % of value added in manufacturing in Philippines per year?
Keep it short and to the point. 11.69. What is the average % of value added in manufacturing in Tanzania per year?
Your answer should be compact. 9.54. In the year 1985, what is the difference between the % of value added in manufacturing of Algeria and % of value added in manufacturing of Morocco?
Keep it short and to the point. -7.85. In the year 1985, what is the difference between the % of value added in manufacturing of Algeria and % of value added in manufacturing of Philippines?
Offer a terse response. -1.44. In the year 1985, what is the difference between the % of value added in manufacturing of Algeria and % of value added in manufacturing of Tanzania?
Your answer should be compact. 1.91. In the year 1985, what is the difference between the % of value added in manufacturing in Morocco and % of value added in manufacturing in Philippines?
Your answer should be compact. 6.42. In the year 1985, what is the difference between the % of value added in manufacturing in Morocco and % of value added in manufacturing in Tanzania?
Your response must be concise. 9.76. In the year 1985, what is the difference between the % of value added in manufacturing in Philippines and % of value added in manufacturing in Tanzania?
Provide a succinct answer. 3.34. In the year 1986, what is the difference between the % of value added in manufacturing of Algeria and % of value added in manufacturing of Morocco?
Keep it short and to the point. -6.21. In the year 1986, what is the difference between the % of value added in manufacturing in Algeria and % of value added in manufacturing in Philippines?
Your answer should be very brief. -4.27. In the year 1986, what is the difference between the % of value added in manufacturing in Algeria and % of value added in manufacturing in Tanzania?
Keep it short and to the point. -1.84. In the year 1986, what is the difference between the % of value added in manufacturing of Morocco and % of value added in manufacturing of Philippines?
Keep it short and to the point. 1.94. In the year 1986, what is the difference between the % of value added in manufacturing in Morocco and % of value added in manufacturing in Tanzania?
Your answer should be very brief. 4.37. In the year 1986, what is the difference between the % of value added in manufacturing in Philippines and % of value added in manufacturing in Tanzania?
Keep it short and to the point. 2.43. In the year 1987, what is the difference between the % of value added in manufacturing in Algeria and % of value added in manufacturing in Morocco?
Your response must be concise. -9.3. In the year 1987, what is the difference between the % of value added in manufacturing in Algeria and % of value added in manufacturing in Philippines?
Your response must be concise. -4.69. In the year 1987, what is the difference between the % of value added in manufacturing in Algeria and % of value added in manufacturing in Tanzania?
Your answer should be compact. -7.87. In the year 1987, what is the difference between the % of value added in manufacturing of Morocco and % of value added in manufacturing of Philippines?
Provide a succinct answer. 4.61. In the year 1987, what is the difference between the % of value added in manufacturing in Morocco and % of value added in manufacturing in Tanzania?
Make the answer very short. 1.42. In the year 1987, what is the difference between the % of value added in manufacturing in Philippines and % of value added in manufacturing in Tanzania?
Your response must be concise. -3.18. In the year 1988, what is the difference between the % of value added in manufacturing of Algeria and % of value added in manufacturing of Morocco?
Give a very brief answer. -10.26. In the year 1988, what is the difference between the % of value added in manufacturing in Algeria and % of value added in manufacturing in Philippines?
Your answer should be compact. -6.16. In the year 1988, what is the difference between the % of value added in manufacturing in Algeria and % of value added in manufacturing in Tanzania?
Offer a terse response. -10.05. In the year 1988, what is the difference between the % of value added in manufacturing in Morocco and % of value added in manufacturing in Philippines?
Your answer should be very brief. 4.1. In the year 1988, what is the difference between the % of value added in manufacturing in Morocco and % of value added in manufacturing in Tanzania?
Give a very brief answer. 0.21. In the year 1988, what is the difference between the % of value added in manufacturing in Philippines and % of value added in manufacturing in Tanzania?
Ensure brevity in your answer.  -3.89. In the year 1990, what is the difference between the % of value added in manufacturing in Algeria and % of value added in manufacturing in Morocco?
Ensure brevity in your answer.  -2.02. In the year 1990, what is the difference between the % of value added in manufacturing in Algeria and % of value added in manufacturing in Philippines?
Keep it short and to the point. -1.58. In the year 1990, what is the difference between the % of value added in manufacturing in Algeria and % of value added in manufacturing in Tanzania?
Your answer should be very brief. -0.76. In the year 1990, what is the difference between the % of value added in manufacturing of Morocco and % of value added in manufacturing of Philippines?
Give a very brief answer. 0.44. In the year 1990, what is the difference between the % of value added in manufacturing of Morocco and % of value added in manufacturing of Tanzania?
Keep it short and to the point. 1.25. In the year 1990, what is the difference between the % of value added in manufacturing in Philippines and % of value added in manufacturing in Tanzania?
Ensure brevity in your answer.  0.81. In the year 1991, what is the difference between the % of value added in manufacturing of Algeria and % of value added in manufacturing of Morocco?
Your response must be concise. 0.28. In the year 1991, what is the difference between the % of value added in manufacturing in Algeria and % of value added in manufacturing in Philippines?
Give a very brief answer. -1.59. In the year 1991, what is the difference between the % of value added in manufacturing of Algeria and % of value added in manufacturing of Tanzania?
Ensure brevity in your answer.  4.87. In the year 1991, what is the difference between the % of value added in manufacturing in Morocco and % of value added in manufacturing in Philippines?
Your answer should be very brief. -1.87. In the year 1991, what is the difference between the % of value added in manufacturing in Morocco and % of value added in manufacturing in Tanzania?
Make the answer very short. 4.6. In the year 1991, what is the difference between the % of value added in manufacturing of Philippines and % of value added in manufacturing of Tanzania?
Provide a succinct answer. 6.47. In the year 1994, what is the difference between the % of value added in manufacturing in Algeria and % of value added in manufacturing in Morocco?
Provide a succinct answer. -4.04. In the year 1994, what is the difference between the % of value added in manufacturing of Algeria and % of value added in manufacturing of Philippines?
Offer a terse response. -2.34. In the year 1994, what is the difference between the % of value added in manufacturing in Algeria and % of value added in manufacturing in Tanzania?
Your answer should be very brief. 4.26. In the year 1994, what is the difference between the % of value added in manufacturing in Morocco and % of value added in manufacturing in Philippines?
Ensure brevity in your answer.  1.7. In the year 1994, what is the difference between the % of value added in manufacturing in Morocco and % of value added in manufacturing in Tanzania?
Offer a terse response. 8.31. In the year 1994, what is the difference between the % of value added in manufacturing in Philippines and % of value added in manufacturing in Tanzania?
Your answer should be very brief. 6.61. In the year 1995, what is the difference between the % of value added in manufacturing in Algeria and % of value added in manufacturing in Morocco?
Provide a short and direct response. -4.53. In the year 1995, what is the difference between the % of value added in manufacturing in Algeria and % of value added in manufacturing in Philippines?
Provide a short and direct response. -1.25. In the year 1995, what is the difference between the % of value added in manufacturing of Algeria and % of value added in manufacturing of Tanzania?
Provide a succinct answer. 3.32. In the year 1995, what is the difference between the % of value added in manufacturing in Morocco and % of value added in manufacturing in Philippines?
Ensure brevity in your answer.  3.28. In the year 1995, what is the difference between the % of value added in manufacturing of Morocco and % of value added in manufacturing of Tanzania?
Offer a very short reply. 7.85. In the year 1995, what is the difference between the % of value added in manufacturing in Philippines and % of value added in manufacturing in Tanzania?
Offer a very short reply. 4.57. What is the ratio of the % of value added in manufacturing of Algeria in 1985 to that in 1986?
Provide a short and direct response. 1.04. What is the ratio of the % of value added in manufacturing of Morocco in 1985 to that in 1986?
Your answer should be very brief. 1.15. What is the ratio of the % of value added in manufacturing in Philippines in 1985 to that in 1986?
Your response must be concise. 0.78. What is the ratio of the % of value added in manufacturing of Tanzania in 1985 to that in 1986?
Provide a short and direct response. 0.62. What is the ratio of the % of value added in manufacturing in Algeria in 1985 to that in 1987?
Provide a succinct answer. 1.31. What is the ratio of the % of value added in manufacturing of Morocco in 1985 to that in 1987?
Give a very brief answer. 1.02. What is the ratio of the % of value added in manufacturing in Philippines in 1985 to that in 1987?
Provide a short and direct response. 0.86. What is the ratio of the % of value added in manufacturing of Tanzania in 1985 to that in 1987?
Ensure brevity in your answer.  0.41. What is the ratio of the % of value added in manufacturing of Algeria in 1985 to that in 1988?
Your response must be concise. 1.22. What is the ratio of the % of value added in manufacturing in Morocco in 1985 to that in 1988?
Your answer should be compact. 0.94. What is the ratio of the % of value added in manufacturing of Philippines in 1985 to that in 1988?
Provide a short and direct response. 0.72. What is the ratio of the % of value added in manufacturing of Tanzania in 1985 to that in 1988?
Provide a succinct answer. 0.34. What is the ratio of the % of value added in manufacturing in Algeria in 1985 to that in 1990?
Offer a terse response. 0.73. What is the ratio of the % of value added in manufacturing of Morocco in 1985 to that in 1990?
Your answer should be very brief. 1.25. What is the ratio of the % of value added in manufacturing of Philippines in 1985 to that in 1990?
Offer a terse response. 0.75. What is the ratio of the % of value added in manufacturing of Tanzania in 1985 to that in 1990?
Your response must be concise. 0.5. What is the ratio of the % of value added in manufacturing in Algeria in 1985 to that in 1991?
Your response must be concise. 0.59. What is the ratio of the % of value added in manufacturing of Morocco in 1985 to that in 1991?
Your answer should be very brief. 1.25. What is the ratio of the % of value added in manufacturing in Philippines in 1985 to that in 1991?
Offer a very short reply. 0.63. What is the ratio of the % of value added in manufacturing in Tanzania in 1985 to that in 1991?
Your answer should be compact. 0.72. What is the ratio of the % of value added in manufacturing of Algeria in 1985 to that in 1994?
Make the answer very short. 0.69. What is the ratio of the % of value added in manufacturing of Morocco in 1985 to that in 1994?
Provide a succinct answer. 1.04. What is the ratio of the % of value added in manufacturing of Philippines in 1985 to that in 1994?
Your response must be concise. 0.68. What is the ratio of the % of value added in manufacturing of Tanzania in 1985 to that in 1994?
Provide a succinct answer. 0.86. What is the ratio of the % of value added in manufacturing in Algeria in 1985 to that in 1995?
Provide a short and direct response. 0.71. What is the ratio of the % of value added in manufacturing in Morocco in 1985 to that in 1995?
Your answer should be compact. 1.02. What is the ratio of the % of value added in manufacturing in Philippines in 1985 to that in 1995?
Your response must be concise. 0.76. What is the ratio of the % of value added in manufacturing in Tanzania in 1985 to that in 1995?
Offer a terse response. 0.77. What is the ratio of the % of value added in manufacturing of Algeria in 1986 to that in 1987?
Your answer should be very brief. 1.26. What is the ratio of the % of value added in manufacturing of Morocco in 1986 to that in 1987?
Provide a succinct answer. 0.89. What is the ratio of the % of value added in manufacturing in Philippines in 1986 to that in 1987?
Provide a succinct answer. 1.1. What is the ratio of the % of value added in manufacturing of Tanzania in 1986 to that in 1987?
Your answer should be very brief. 0.66. What is the ratio of the % of value added in manufacturing of Algeria in 1986 to that in 1988?
Make the answer very short. 1.17. What is the ratio of the % of value added in manufacturing of Morocco in 1986 to that in 1988?
Your response must be concise. 0.82. What is the ratio of the % of value added in manufacturing of Philippines in 1986 to that in 1988?
Offer a very short reply. 0.93. What is the ratio of the % of value added in manufacturing of Tanzania in 1986 to that in 1988?
Make the answer very short. 0.56. What is the ratio of the % of value added in manufacturing of Algeria in 1986 to that in 1990?
Your response must be concise. 0.7. What is the ratio of the % of value added in manufacturing in Morocco in 1986 to that in 1990?
Ensure brevity in your answer.  1.09. What is the ratio of the % of value added in manufacturing in Philippines in 1986 to that in 1990?
Offer a terse response. 0.97. What is the ratio of the % of value added in manufacturing in Tanzania in 1986 to that in 1990?
Your answer should be very brief. 0.82. What is the ratio of the % of value added in manufacturing of Algeria in 1986 to that in 1991?
Ensure brevity in your answer.  0.57. What is the ratio of the % of value added in manufacturing of Morocco in 1986 to that in 1991?
Your answer should be compact. 1.09. What is the ratio of the % of value added in manufacturing of Philippines in 1986 to that in 1991?
Provide a short and direct response. 0.81. What is the ratio of the % of value added in manufacturing in Tanzania in 1986 to that in 1991?
Your response must be concise. 1.18. What is the ratio of the % of value added in manufacturing of Algeria in 1986 to that in 1994?
Keep it short and to the point. 0.67. What is the ratio of the % of value added in manufacturing of Morocco in 1986 to that in 1994?
Keep it short and to the point. 0.91. What is the ratio of the % of value added in manufacturing in Philippines in 1986 to that in 1994?
Provide a succinct answer. 0.87. What is the ratio of the % of value added in manufacturing of Tanzania in 1986 to that in 1994?
Give a very brief answer. 1.4. What is the ratio of the % of value added in manufacturing of Algeria in 1986 to that in 1995?
Make the answer very short. 0.68. What is the ratio of the % of value added in manufacturing in Morocco in 1986 to that in 1995?
Your answer should be compact. 0.89. What is the ratio of the % of value added in manufacturing in Philippines in 1986 to that in 1995?
Give a very brief answer. 0.97. What is the ratio of the % of value added in manufacturing of Tanzania in 1986 to that in 1995?
Your answer should be very brief. 1.26. What is the ratio of the % of value added in manufacturing in Algeria in 1987 to that in 1988?
Provide a short and direct response. 0.93. What is the ratio of the % of value added in manufacturing in Morocco in 1987 to that in 1988?
Your answer should be very brief. 0.92. What is the ratio of the % of value added in manufacturing in Philippines in 1987 to that in 1988?
Keep it short and to the point. 0.85. What is the ratio of the % of value added in manufacturing of Tanzania in 1987 to that in 1988?
Ensure brevity in your answer.  0.84. What is the ratio of the % of value added in manufacturing of Algeria in 1987 to that in 1990?
Offer a terse response. 0.55. What is the ratio of the % of value added in manufacturing in Morocco in 1987 to that in 1990?
Make the answer very short. 1.22. What is the ratio of the % of value added in manufacturing of Philippines in 1987 to that in 1990?
Provide a succinct answer. 0.88. What is the ratio of the % of value added in manufacturing of Tanzania in 1987 to that in 1990?
Offer a terse response. 1.23. What is the ratio of the % of value added in manufacturing in Algeria in 1987 to that in 1991?
Your answer should be very brief. 0.45. What is the ratio of the % of value added in manufacturing of Morocco in 1987 to that in 1991?
Provide a short and direct response. 1.22. What is the ratio of the % of value added in manufacturing in Philippines in 1987 to that in 1991?
Offer a very short reply. 0.73. What is the ratio of the % of value added in manufacturing in Tanzania in 1987 to that in 1991?
Offer a very short reply. 1.78. What is the ratio of the % of value added in manufacturing of Algeria in 1987 to that in 1994?
Offer a very short reply. 0.53. What is the ratio of the % of value added in manufacturing of Morocco in 1987 to that in 1994?
Keep it short and to the point. 1.02. What is the ratio of the % of value added in manufacturing of Philippines in 1987 to that in 1994?
Offer a terse response. 0.79. What is the ratio of the % of value added in manufacturing of Tanzania in 1987 to that in 1994?
Provide a short and direct response. 2.11. What is the ratio of the % of value added in manufacturing in Algeria in 1987 to that in 1995?
Your answer should be compact. 0.54. What is the ratio of the % of value added in manufacturing of Morocco in 1987 to that in 1995?
Make the answer very short. 1. What is the ratio of the % of value added in manufacturing in Philippines in 1987 to that in 1995?
Give a very brief answer. 0.88. What is the ratio of the % of value added in manufacturing of Tanzania in 1987 to that in 1995?
Provide a short and direct response. 1.9. What is the ratio of the % of value added in manufacturing of Algeria in 1988 to that in 1990?
Your answer should be very brief. 0.59. What is the ratio of the % of value added in manufacturing of Morocco in 1988 to that in 1990?
Your answer should be very brief. 1.33. What is the ratio of the % of value added in manufacturing in Philippines in 1988 to that in 1990?
Keep it short and to the point. 1.04. What is the ratio of the % of value added in manufacturing in Tanzania in 1988 to that in 1990?
Offer a terse response. 1.47. What is the ratio of the % of value added in manufacturing in Algeria in 1988 to that in 1991?
Keep it short and to the point. 0.49. What is the ratio of the % of value added in manufacturing in Morocco in 1988 to that in 1991?
Make the answer very short. 1.34. What is the ratio of the % of value added in manufacturing of Philippines in 1988 to that in 1991?
Your response must be concise. 0.87. What is the ratio of the % of value added in manufacturing of Tanzania in 1988 to that in 1991?
Provide a short and direct response. 2.11. What is the ratio of the % of value added in manufacturing of Algeria in 1988 to that in 1994?
Offer a terse response. 0.57. What is the ratio of the % of value added in manufacturing in Morocco in 1988 to that in 1994?
Provide a short and direct response. 1.11. What is the ratio of the % of value added in manufacturing of Philippines in 1988 to that in 1994?
Give a very brief answer. 0.94. What is the ratio of the % of value added in manufacturing in Tanzania in 1988 to that in 1994?
Your answer should be very brief. 2.51. What is the ratio of the % of value added in manufacturing of Algeria in 1988 to that in 1995?
Give a very brief answer. 0.58. What is the ratio of the % of value added in manufacturing of Morocco in 1988 to that in 1995?
Your answer should be compact. 1.09. What is the ratio of the % of value added in manufacturing in Philippines in 1988 to that in 1995?
Keep it short and to the point. 1.05. What is the ratio of the % of value added in manufacturing of Tanzania in 1988 to that in 1995?
Offer a very short reply. 2.26. What is the ratio of the % of value added in manufacturing of Algeria in 1990 to that in 1991?
Give a very brief answer. 0.82. What is the ratio of the % of value added in manufacturing of Morocco in 1990 to that in 1991?
Provide a succinct answer. 1. What is the ratio of the % of value added in manufacturing in Philippines in 1990 to that in 1991?
Your answer should be very brief. 0.84. What is the ratio of the % of value added in manufacturing of Tanzania in 1990 to that in 1991?
Ensure brevity in your answer.  1.44. What is the ratio of the % of value added in manufacturing in Algeria in 1990 to that in 1994?
Keep it short and to the point. 0.96. What is the ratio of the % of value added in manufacturing in Morocco in 1990 to that in 1994?
Offer a terse response. 0.83. What is the ratio of the % of value added in manufacturing of Philippines in 1990 to that in 1994?
Your answer should be very brief. 0.91. What is the ratio of the % of value added in manufacturing in Tanzania in 1990 to that in 1994?
Keep it short and to the point. 1.71. What is the ratio of the % of value added in manufacturing of Algeria in 1990 to that in 1995?
Keep it short and to the point. 0.98. What is the ratio of the % of value added in manufacturing of Morocco in 1990 to that in 1995?
Your answer should be very brief. 0.82. What is the ratio of the % of value added in manufacturing in Tanzania in 1990 to that in 1995?
Your answer should be compact. 1.54. What is the ratio of the % of value added in manufacturing in Algeria in 1991 to that in 1994?
Ensure brevity in your answer.  1.17. What is the ratio of the % of value added in manufacturing in Morocco in 1991 to that in 1994?
Ensure brevity in your answer.  0.83. What is the ratio of the % of value added in manufacturing in Philippines in 1991 to that in 1994?
Provide a succinct answer. 1.08. What is the ratio of the % of value added in manufacturing in Tanzania in 1991 to that in 1994?
Your answer should be compact. 1.19. What is the ratio of the % of value added in manufacturing in Algeria in 1991 to that in 1995?
Offer a terse response. 1.2. What is the ratio of the % of value added in manufacturing of Morocco in 1991 to that in 1995?
Offer a very short reply. 0.82. What is the ratio of the % of value added in manufacturing of Philippines in 1991 to that in 1995?
Offer a terse response. 1.2. What is the ratio of the % of value added in manufacturing of Tanzania in 1991 to that in 1995?
Your response must be concise. 1.07. What is the ratio of the % of value added in manufacturing of Algeria in 1994 to that in 1995?
Make the answer very short. 1.02. What is the ratio of the % of value added in manufacturing in Morocco in 1994 to that in 1995?
Offer a very short reply. 0.98. What is the ratio of the % of value added in manufacturing of Philippines in 1994 to that in 1995?
Your response must be concise. 1.11. What is the ratio of the % of value added in manufacturing of Tanzania in 1994 to that in 1995?
Your response must be concise. 0.9. What is the difference between the highest and the second highest % of value added in manufacturing of Algeria?
Keep it short and to the point. 1.81. What is the difference between the highest and the second highest % of value added in manufacturing in Morocco?
Your answer should be compact. 1.05. What is the difference between the highest and the second highest % of value added in manufacturing of Philippines?
Provide a succinct answer. 1.06. What is the difference between the highest and the second highest % of value added in manufacturing in Tanzania?
Offer a very short reply. 2.59. What is the difference between the highest and the lowest % of value added in manufacturing of Algeria?
Your answer should be very brief. 6.83. What is the difference between the highest and the lowest % of value added in manufacturing of Morocco?
Keep it short and to the point. 4.11. What is the difference between the highest and the lowest % of value added in manufacturing in Philippines?
Offer a very short reply. 5.23. What is the difference between the highest and the lowest % of value added in manufacturing of Tanzania?
Offer a terse response. 10.61. 